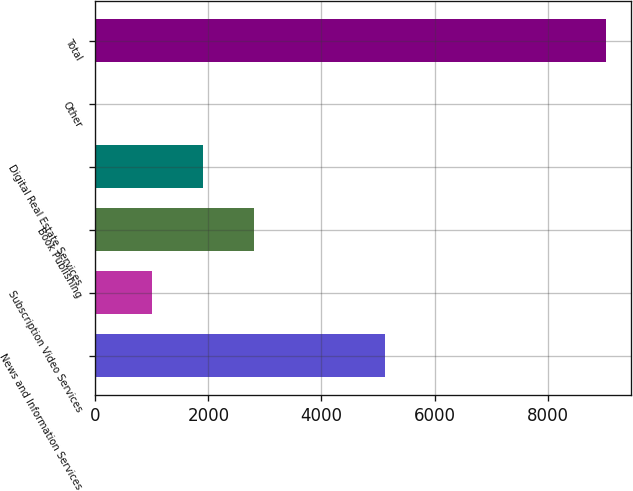<chart> <loc_0><loc_0><loc_500><loc_500><bar_chart><fcel>News and Information Services<fcel>Subscription Video Services<fcel>Book Publishing<fcel>Digital Real Estate Services<fcel>Other<fcel>Total<nl><fcel>5119<fcel>1004<fcel>2808.4<fcel>1906.2<fcel>2<fcel>9024<nl></chart> 